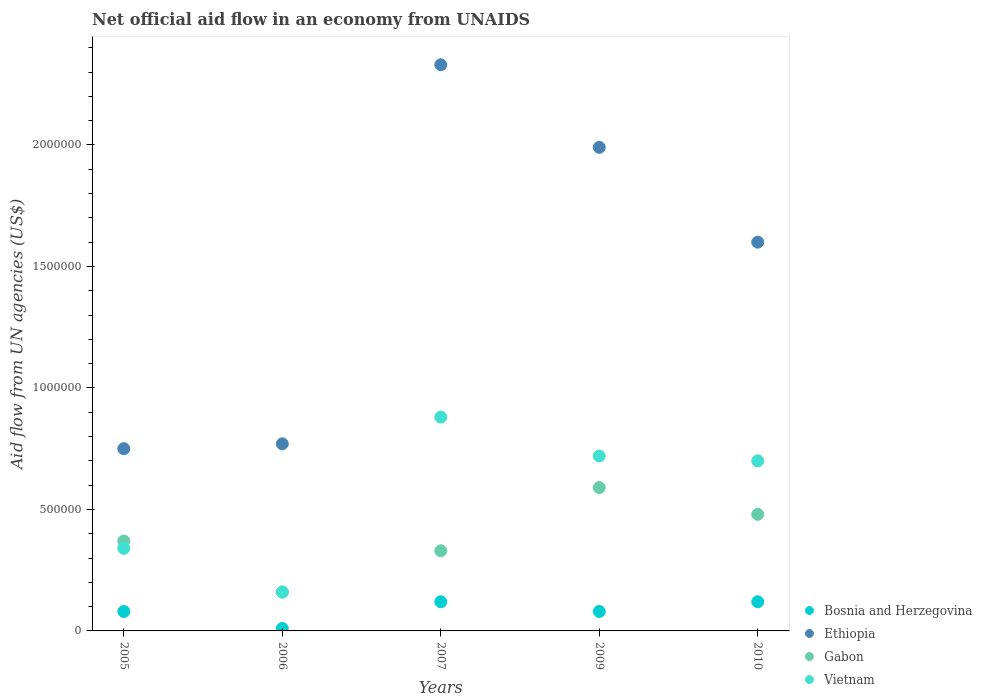How many different coloured dotlines are there?
Offer a very short reply. 4. Is the number of dotlines equal to the number of legend labels?
Offer a very short reply. Yes. What is the net official aid flow in Ethiopia in 2006?
Provide a short and direct response. 7.70e+05. Across all years, what is the maximum net official aid flow in Gabon?
Offer a terse response. 5.90e+05. Across all years, what is the minimum net official aid flow in Ethiopia?
Provide a succinct answer. 7.50e+05. In which year was the net official aid flow in Bosnia and Herzegovina maximum?
Your response must be concise. 2007. What is the total net official aid flow in Gabon in the graph?
Your answer should be very brief. 1.93e+06. What is the difference between the net official aid flow in Ethiopia in 2007 and that in 2009?
Make the answer very short. 3.40e+05. What is the difference between the net official aid flow in Gabon in 2006 and the net official aid flow in Ethiopia in 2005?
Provide a succinct answer. -5.90e+05. What is the average net official aid flow in Ethiopia per year?
Provide a short and direct response. 1.49e+06. In the year 2010, what is the difference between the net official aid flow in Bosnia and Herzegovina and net official aid flow in Gabon?
Keep it short and to the point. -3.60e+05. What is the ratio of the net official aid flow in Bosnia and Herzegovina in 2006 to that in 2007?
Offer a terse response. 0.08. Is the net official aid flow in Ethiopia in 2006 less than that in 2007?
Keep it short and to the point. Yes. Is the difference between the net official aid flow in Bosnia and Herzegovina in 2005 and 2006 greater than the difference between the net official aid flow in Gabon in 2005 and 2006?
Offer a terse response. No. What is the difference between the highest and the second highest net official aid flow in Vietnam?
Provide a short and direct response. 1.60e+05. What is the difference between the highest and the lowest net official aid flow in Bosnia and Herzegovina?
Your answer should be compact. 1.10e+05. Is it the case that in every year, the sum of the net official aid flow in Bosnia and Herzegovina and net official aid flow in Ethiopia  is greater than the sum of net official aid flow in Vietnam and net official aid flow in Gabon?
Keep it short and to the point. Yes. Does the net official aid flow in Gabon monotonically increase over the years?
Make the answer very short. No. Is the net official aid flow in Vietnam strictly less than the net official aid flow in Ethiopia over the years?
Offer a terse response. Yes. How many dotlines are there?
Your response must be concise. 4. How many years are there in the graph?
Keep it short and to the point. 5. Does the graph contain any zero values?
Ensure brevity in your answer.  No. Does the graph contain grids?
Give a very brief answer. No. Where does the legend appear in the graph?
Your answer should be very brief. Bottom right. How many legend labels are there?
Your answer should be compact. 4. How are the legend labels stacked?
Offer a very short reply. Vertical. What is the title of the graph?
Give a very brief answer. Net official aid flow in an economy from UNAIDS. Does "Fiji" appear as one of the legend labels in the graph?
Your response must be concise. No. What is the label or title of the Y-axis?
Keep it short and to the point. Aid flow from UN agencies (US$). What is the Aid flow from UN agencies (US$) in Ethiopia in 2005?
Your response must be concise. 7.50e+05. What is the Aid flow from UN agencies (US$) in Gabon in 2005?
Provide a succinct answer. 3.70e+05. What is the Aid flow from UN agencies (US$) of Vietnam in 2005?
Ensure brevity in your answer.  3.40e+05. What is the Aid flow from UN agencies (US$) in Bosnia and Herzegovina in 2006?
Keep it short and to the point. 10000. What is the Aid flow from UN agencies (US$) of Ethiopia in 2006?
Your answer should be very brief. 7.70e+05. What is the Aid flow from UN agencies (US$) in Bosnia and Herzegovina in 2007?
Offer a very short reply. 1.20e+05. What is the Aid flow from UN agencies (US$) of Ethiopia in 2007?
Make the answer very short. 2.33e+06. What is the Aid flow from UN agencies (US$) of Vietnam in 2007?
Keep it short and to the point. 8.80e+05. What is the Aid flow from UN agencies (US$) in Ethiopia in 2009?
Keep it short and to the point. 1.99e+06. What is the Aid flow from UN agencies (US$) in Gabon in 2009?
Keep it short and to the point. 5.90e+05. What is the Aid flow from UN agencies (US$) of Vietnam in 2009?
Provide a short and direct response. 7.20e+05. What is the Aid flow from UN agencies (US$) in Ethiopia in 2010?
Offer a terse response. 1.60e+06. What is the Aid flow from UN agencies (US$) of Gabon in 2010?
Ensure brevity in your answer.  4.80e+05. What is the Aid flow from UN agencies (US$) in Vietnam in 2010?
Make the answer very short. 7.00e+05. Across all years, what is the maximum Aid flow from UN agencies (US$) in Ethiopia?
Make the answer very short. 2.33e+06. Across all years, what is the maximum Aid flow from UN agencies (US$) of Gabon?
Give a very brief answer. 5.90e+05. Across all years, what is the maximum Aid flow from UN agencies (US$) of Vietnam?
Your answer should be very brief. 8.80e+05. Across all years, what is the minimum Aid flow from UN agencies (US$) in Bosnia and Herzegovina?
Provide a short and direct response. 10000. Across all years, what is the minimum Aid flow from UN agencies (US$) in Ethiopia?
Ensure brevity in your answer.  7.50e+05. What is the total Aid flow from UN agencies (US$) of Bosnia and Herzegovina in the graph?
Keep it short and to the point. 4.10e+05. What is the total Aid flow from UN agencies (US$) of Ethiopia in the graph?
Make the answer very short. 7.44e+06. What is the total Aid flow from UN agencies (US$) of Gabon in the graph?
Your response must be concise. 1.93e+06. What is the total Aid flow from UN agencies (US$) of Vietnam in the graph?
Keep it short and to the point. 2.80e+06. What is the difference between the Aid flow from UN agencies (US$) of Bosnia and Herzegovina in 2005 and that in 2006?
Your response must be concise. 7.00e+04. What is the difference between the Aid flow from UN agencies (US$) of Gabon in 2005 and that in 2006?
Provide a short and direct response. 2.10e+05. What is the difference between the Aid flow from UN agencies (US$) of Ethiopia in 2005 and that in 2007?
Offer a very short reply. -1.58e+06. What is the difference between the Aid flow from UN agencies (US$) in Gabon in 2005 and that in 2007?
Ensure brevity in your answer.  4.00e+04. What is the difference between the Aid flow from UN agencies (US$) of Vietnam in 2005 and that in 2007?
Your response must be concise. -5.40e+05. What is the difference between the Aid flow from UN agencies (US$) of Ethiopia in 2005 and that in 2009?
Keep it short and to the point. -1.24e+06. What is the difference between the Aid flow from UN agencies (US$) of Gabon in 2005 and that in 2009?
Your answer should be compact. -2.20e+05. What is the difference between the Aid flow from UN agencies (US$) in Vietnam in 2005 and that in 2009?
Keep it short and to the point. -3.80e+05. What is the difference between the Aid flow from UN agencies (US$) in Bosnia and Herzegovina in 2005 and that in 2010?
Make the answer very short. -4.00e+04. What is the difference between the Aid flow from UN agencies (US$) in Ethiopia in 2005 and that in 2010?
Give a very brief answer. -8.50e+05. What is the difference between the Aid flow from UN agencies (US$) of Vietnam in 2005 and that in 2010?
Give a very brief answer. -3.60e+05. What is the difference between the Aid flow from UN agencies (US$) of Ethiopia in 2006 and that in 2007?
Your answer should be very brief. -1.56e+06. What is the difference between the Aid flow from UN agencies (US$) in Vietnam in 2006 and that in 2007?
Ensure brevity in your answer.  -7.20e+05. What is the difference between the Aid flow from UN agencies (US$) in Bosnia and Herzegovina in 2006 and that in 2009?
Your response must be concise. -7.00e+04. What is the difference between the Aid flow from UN agencies (US$) in Ethiopia in 2006 and that in 2009?
Provide a short and direct response. -1.22e+06. What is the difference between the Aid flow from UN agencies (US$) of Gabon in 2006 and that in 2009?
Offer a terse response. -4.30e+05. What is the difference between the Aid flow from UN agencies (US$) in Vietnam in 2006 and that in 2009?
Give a very brief answer. -5.60e+05. What is the difference between the Aid flow from UN agencies (US$) in Bosnia and Herzegovina in 2006 and that in 2010?
Offer a terse response. -1.10e+05. What is the difference between the Aid flow from UN agencies (US$) in Ethiopia in 2006 and that in 2010?
Provide a short and direct response. -8.30e+05. What is the difference between the Aid flow from UN agencies (US$) of Gabon in 2006 and that in 2010?
Your response must be concise. -3.20e+05. What is the difference between the Aid flow from UN agencies (US$) of Vietnam in 2006 and that in 2010?
Keep it short and to the point. -5.40e+05. What is the difference between the Aid flow from UN agencies (US$) of Bosnia and Herzegovina in 2007 and that in 2009?
Offer a terse response. 4.00e+04. What is the difference between the Aid flow from UN agencies (US$) in Gabon in 2007 and that in 2009?
Provide a succinct answer. -2.60e+05. What is the difference between the Aid flow from UN agencies (US$) of Vietnam in 2007 and that in 2009?
Offer a terse response. 1.60e+05. What is the difference between the Aid flow from UN agencies (US$) of Bosnia and Herzegovina in 2007 and that in 2010?
Ensure brevity in your answer.  0. What is the difference between the Aid flow from UN agencies (US$) in Ethiopia in 2007 and that in 2010?
Provide a succinct answer. 7.30e+05. What is the difference between the Aid flow from UN agencies (US$) of Vietnam in 2007 and that in 2010?
Give a very brief answer. 1.80e+05. What is the difference between the Aid flow from UN agencies (US$) of Ethiopia in 2009 and that in 2010?
Offer a terse response. 3.90e+05. What is the difference between the Aid flow from UN agencies (US$) in Gabon in 2009 and that in 2010?
Make the answer very short. 1.10e+05. What is the difference between the Aid flow from UN agencies (US$) of Bosnia and Herzegovina in 2005 and the Aid flow from UN agencies (US$) of Ethiopia in 2006?
Offer a very short reply. -6.90e+05. What is the difference between the Aid flow from UN agencies (US$) of Bosnia and Herzegovina in 2005 and the Aid flow from UN agencies (US$) of Vietnam in 2006?
Offer a very short reply. -8.00e+04. What is the difference between the Aid flow from UN agencies (US$) in Ethiopia in 2005 and the Aid flow from UN agencies (US$) in Gabon in 2006?
Ensure brevity in your answer.  5.90e+05. What is the difference between the Aid flow from UN agencies (US$) of Ethiopia in 2005 and the Aid flow from UN agencies (US$) of Vietnam in 2006?
Your answer should be compact. 5.90e+05. What is the difference between the Aid flow from UN agencies (US$) in Gabon in 2005 and the Aid flow from UN agencies (US$) in Vietnam in 2006?
Keep it short and to the point. 2.10e+05. What is the difference between the Aid flow from UN agencies (US$) of Bosnia and Herzegovina in 2005 and the Aid flow from UN agencies (US$) of Ethiopia in 2007?
Your response must be concise. -2.25e+06. What is the difference between the Aid flow from UN agencies (US$) in Bosnia and Herzegovina in 2005 and the Aid flow from UN agencies (US$) in Vietnam in 2007?
Provide a succinct answer. -8.00e+05. What is the difference between the Aid flow from UN agencies (US$) of Ethiopia in 2005 and the Aid flow from UN agencies (US$) of Gabon in 2007?
Your response must be concise. 4.20e+05. What is the difference between the Aid flow from UN agencies (US$) of Gabon in 2005 and the Aid flow from UN agencies (US$) of Vietnam in 2007?
Ensure brevity in your answer.  -5.10e+05. What is the difference between the Aid flow from UN agencies (US$) in Bosnia and Herzegovina in 2005 and the Aid flow from UN agencies (US$) in Ethiopia in 2009?
Your answer should be compact. -1.91e+06. What is the difference between the Aid flow from UN agencies (US$) in Bosnia and Herzegovina in 2005 and the Aid flow from UN agencies (US$) in Gabon in 2009?
Offer a very short reply. -5.10e+05. What is the difference between the Aid flow from UN agencies (US$) of Bosnia and Herzegovina in 2005 and the Aid flow from UN agencies (US$) of Vietnam in 2009?
Give a very brief answer. -6.40e+05. What is the difference between the Aid flow from UN agencies (US$) of Ethiopia in 2005 and the Aid flow from UN agencies (US$) of Vietnam in 2009?
Provide a short and direct response. 3.00e+04. What is the difference between the Aid flow from UN agencies (US$) in Gabon in 2005 and the Aid flow from UN agencies (US$) in Vietnam in 2009?
Keep it short and to the point. -3.50e+05. What is the difference between the Aid flow from UN agencies (US$) of Bosnia and Herzegovina in 2005 and the Aid flow from UN agencies (US$) of Ethiopia in 2010?
Keep it short and to the point. -1.52e+06. What is the difference between the Aid flow from UN agencies (US$) of Bosnia and Herzegovina in 2005 and the Aid flow from UN agencies (US$) of Gabon in 2010?
Keep it short and to the point. -4.00e+05. What is the difference between the Aid flow from UN agencies (US$) of Bosnia and Herzegovina in 2005 and the Aid flow from UN agencies (US$) of Vietnam in 2010?
Give a very brief answer. -6.20e+05. What is the difference between the Aid flow from UN agencies (US$) in Ethiopia in 2005 and the Aid flow from UN agencies (US$) in Vietnam in 2010?
Provide a succinct answer. 5.00e+04. What is the difference between the Aid flow from UN agencies (US$) in Gabon in 2005 and the Aid flow from UN agencies (US$) in Vietnam in 2010?
Offer a terse response. -3.30e+05. What is the difference between the Aid flow from UN agencies (US$) in Bosnia and Herzegovina in 2006 and the Aid flow from UN agencies (US$) in Ethiopia in 2007?
Your response must be concise. -2.32e+06. What is the difference between the Aid flow from UN agencies (US$) in Bosnia and Herzegovina in 2006 and the Aid flow from UN agencies (US$) in Gabon in 2007?
Offer a very short reply. -3.20e+05. What is the difference between the Aid flow from UN agencies (US$) in Bosnia and Herzegovina in 2006 and the Aid flow from UN agencies (US$) in Vietnam in 2007?
Make the answer very short. -8.70e+05. What is the difference between the Aid flow from UN agencies (US$) of Ethiopia in 2006 and the Aid flow from UN agencies (US$) of Gabon in 2007?
Offer a terse response. 4.40e+05. What is the difference between the Aid flow from UN agencies (US$) in Gabon in 2006 and the Aid flow from UN agencies (US$) in Vietnam in 2007?
Provide a succinct answer. -7.20e+05. What is the difference between the Aid flow from UN agencies (US$) of Bosnia and Herzegovina in 2006 and the Aid flow from UN agencies (US$) of Ethiopia in 2009?
Ensure brevity in your answer.  -1.98e+06. What is the difference between the Aid flow from UN agencies (US$) of Bosnia and Herzegovina in 2006 and the Aid flow from UN agencies (US$) of Gabon in 2009?
Keep it short and to the point. -5.80e+05. What is the difference between the Aid flow from UN agencies (US$) in Bosnia and Herzegovina in 2006 and the Aid flow from UN agencies (US$) in Vietnam in 2009?
Ensure brevity in your answer.  -7.10e+05. What is the difference between the Aid flow from UN agencies (US$) in Ethiopia in 2006 and the Aid flow from UN agencies (US$) in Gabon in 2009?
Keep it short and to the point. 1.80e+05. What is the difference between the Aid flow from UN agencies (US$) of Gabon in 2006 and the Aid flow from UN agencies (US$) of Vietnam in 2009?
Your answer should be very brief. -5.60e+05. What is the difference between the Aid flow from UN agencies (US$) of Bosnia and Herzegovina in 2006 and the Aid flow from UN agencies (US$) of Ethiopia in 2010?
Provide a succinct answer. -1.59e+06. What is the difference between the Aid flow from UN agencies (US$) in Bosnia and Herzegovina in 2006 and the Aid flow from UN agencies (US$) in Gabon in 2010?
Provide a short and direct response. -4.70e+05. What is the difference between the Aid flow from UN agencies (US$) of Bosnia and Herzegovina in 2006 and the Aid flow from UN agencies (US$) of Vietnam in 2010?
Offer a very short reply. -6.90e+05. What is the difference between the Aid flow from UN agencies (US$) in Gabon in 2006 and the Aid flow from UN agencies (US$) in Vietnam in 2010?
Offer a terse response. -5.40e+05. What is the difference between the Aid flow from UN agencies (US$) in Bosnia and Herzegovina in 2007 and the Aid flow from UN agencies (US$) in Ethiopia in 2009?
Offer a terse response. -1.87e+06. What is the difference between the Aid flow from UN agencies (US$) in Bosnia and Herzegovina in 2007 and the Aid flow from UN agencies (US$) in Gabon in 2009?
Provide a short and direct response. -4.70e+05. What is the difference between the Aid flow from UN agencies (US$) in Bosnia and Herzegovina in 2007 and the Aid flow from UN agencies (US$) in Vietnam in 2009?
Offer a terse response. -6.00e+05. What is the difference between the Aid flow from UN agencies (US$) in Ethiopia in 2007 and the Aid flow from UN agencies (US$) in Gabon in 2009?
Give a very brief answer. 1.74e+06. What is the difference between the Aid flow from UN agencies (US$) in Ethiopia in 2007 and the Aid flow from UN agencies (US$) in Vietnam in 2009?
Give a very brief answer. 1.61e+06. What is the difference between the Aid flow from UN agencies (US$) in Gabon in 2007 and the Aid flow from UN agencies (US$) in Vietnam in 2009?
Provide a succinct answer. -3.90e+05. What is the difference between the Aid flow from UN agencies (US$) in Bosnia and Herzegovina in 2007 and the Aid flow from UN agencies (US$) in Ethiopia in 2010?
Offer a very short reply. -1.48e+06. What is the difference between the Aid flow from UN agencies (US$) in Bosnia and Herzegovina in 2007 and the Aid flow from UN agencies (US$) in Gabon in 2010?
Your answer should be very brief. -3.60e+05. What is the difference between the Aid flow from UN agencies (US$) of Bosnia and Herzegovina in 2007 and the Aid flow from UN agencies (US$) of Vietnam in 2010?
Make the answer very short. -5.80e+05. What is the difference between the Aid flow from UN agencies (US$) of Ethiopia in 2007 and the Aid flow from UN agencies (US$) of Gabon in 2010?
Give a very brief answer. 1.85e+06. What is the difference between the Aid flow from UN agencies (US$) in Ethiopia in 2007 and the Aid flow from UN agencies (US$) in Vietnam in 2010?
Provide a short and direct response. 1.63e+06. What is the difference between the Aid flow from UN agencies (US$) in Gabon in 2007 and the Aid flow from UN agencies (US$) in Vietnam in 2010?
Make the answer very short. -3.70e+05. What is the difference between the Aid flow from UN agencies (US$) of Bosnia and Herzegovina in 2009 and the Aid flow from UN agencies (US$) of Ethiopia in 2010?
Ensure brevity in your answer.  -1.52e+06. What is the difference between the Aid flow from UN agencies (US$) in Bosnia and Herzegovina in 2009 and the Aid flow from UN agencies (US$) in Gabon in 2010?
Your answer should be very brief. -4.00e+05. What is the difference between the Aid flow from UN agencies (US$) of Bosnia and Herzegovina in 2009 and the Aid flow from UN agencies (US$) of Vietnam in 2010?
Offer a very short reply. -6.20e+05. What is the difference between the Aid flow from UN agencies (US$) of Ethiopia in 2009 and the Aid flow from UN agencies (US$) of Gabon in 2010?
Your response must be concise. 1.51e+06. What is the difference between the Aid flow from UN agencies (US$) in Ethiopia in 2009 and the Aid flow from UN agencies (US$) in Vietnam in 2010?
Make the answer very short. 1.29e+06. What is the average Aid flow from UN agencies (US$) in Bosnia and Herzegovina per year?
Give a very brief answer. 8.20e+04. What is the average Aid flow from UN agencies (US$) in Ethiopia per year?
Your answer should be very brief. 1.49e+06. What is the average Aid flow from UN agencies (US$) of Gabon per year?
Your answer should be very brief. 3.86e+05. What is the average Aid flow from UN agencies (US$) in Vietnam per year?
Provide a short and direct response. 5.60e+05. In the year 2005, what is the difference between the Aid flow from UN agencies (US$) in Bosnia and Herzegovina and Aid flow from UN agencies (US$) in Ethiopia?
Give a very brief answer. -6.70e+05. In the year 2005, what is the difference between the Aid flow from UN agencies (US$) of Bosnia and Herzegovina and Aid flow from UN agencies (US$) of Gabon?
Your answer should be compact. -2.90e+05. In the year 2005, what is the difference between the Aid flow from UN agencies (US$) in Bosnia and Herzegovina and Aid flow from UN agencies (US$) in Vietnam?
Provide a succinct answer. -2.60e+05. In the year 2005, what is the difference between the Aid flow from UN agencies (US$) of Ethiopia and Aid flow from UN agencies (US$) of Vietnam?
Keep it short and to the point. 4.10e+05. In the year 2005, what is the difference between the Aid flow from UN agencies (US$) in Gabon and Aid flow from UN agencies (US$) in Vietnam?
Your answer should be very brief. 3.00e+04. In the year 2006, what is the difference between the Aid flow from UN agencies (US$) of Bosnia and Herzegovina and Aid flow from UN agencies (US$) of Ethiopia?
Offer a very short reply. -7.60e+05. In the year 2006, what is the difference between the Aid flow from UN agencies (US$) of Bosnia and Herzegovina and Aid flow from UN agencies (US$) of Vietnam?
Provide a short and direct response. -1.50e+05. In the year 2006, what is the difference between the Aid flow from UN agencies (US$) in Ethiopia and Aid flow from UN agencies (US$) in Gabon?
Ensure brevity in your answer.  6.10e+05. In the year 2006, what is the difference between the Aid flow from UN agencies (US$) of Ethiopia and Aid flow from UN agencies (US$) of Vietnam?
Make the answer very short. 6.10e+05. In the year 2006, what is the difference between the Aid flow from UN agencies (US$) in Gabon and Aid flow from UN agencies (US$) in Vietnam?
Your response must be concise. 0. In the year 2007, what is the difference between the Aid flow from UN agencies (US$) in Bosnia and Herzegovina and Aid flow from UN agencies (US$) in Ethiopia?
Make the answer very short. -2.21e+06. In the year 2007, what is the difference between the Aid flow from UN agencies (US$) of Bosnia and Herzegovina and Aid flow from UN agencies (US$) of Vietnam?
Your answer should be compact. -7.60e+05. In the year 2007, what is the difference between the Aid flow from UN agencies (US$) of Ethiopia and Aid flow from UN agencies (US$) of Gabon?
Make the answer very short. 2.00e+06. In the year 2007, what is the difference between the Aid flow from UN agencies (US$) in Ethiopia and Aid flow from UN agencies (US$) in Vietnam?
Offer a very short reply. 1.45e+06. In the year 2007, what is the difference between the Aid flow from UN agencies (US$) of Gabon and Aid flow from UN agencies (US$) of Vietnam?
Keep it short and to the point. -5.50e+05. In the year 2009, what is the difference between the Aid flow from UN agencies (US$) of Bosnia and Herzegovina and Aid flow from UN agencies (US$) of Ethiopia?
Your response must be concise. -1.91e+06. In the year 2009, what is the difference between the Aid flow from UN agencies (US$) in Bosnia and Herzegovina and Aid flow from UN agencies (US$) in Gabon?
Give a very brief answer. -5.10e+05. In the year 2009, what is the difference between the Aid flow from UN agencies (US$) in Bosnia and Herzegovina and Aid flow from UN agencies (US$) in Vietnam?
Provide a succinct answer. -6.40e+05. In the year 2009, what is the difference between the Aid flow from UN agencies (US$) of Ethiopia and Aid flow from UN agencies (US$) of Gabon?
Your answer should be very brief. 1.40e+06. In the year 2009, what is the difference between the Aid flow from UN agencies (US$) in Ethiopia and Aid flow from UN agencies (US$) in Vietnam?
Give a very brief answer. 1.27e+06. In the year 2009, what is the difference between the Aid flow from UN agencies (US$) in Gabon and Aid flow from UN agencies (US$) in Vietnam?
Your answer should be compact. -1.30e+05. In the year 2010, what is the difference between the Aid flow from UN agencies (US$) in Bosnia and Herzegovina and Aid flow from UN agencies (US$) in Ethiopia?
Your answer should be very brief. -1.48e+06. In the year 2010, what is the difference between the Aid flow from UN agencies (US$) in Bosnia and Herzegovina and Aid flow from UN agencies (US$) in Gabon?
Make the answer very short. -3.60e+05. In the year 2010, what is the difference between the Aid flow from UN agencies (US$) in Bosnia and Herzegovina and Aid flow from UN agencies (US$) in Vietnam?
Ensure brevity in your answer.  -5.80e+05. In the year 2010, what is the difference between the Aid flow from UN agencies (US$) in Ethiopia and Aid flow from UN agencies (US$) in Gabon?
Make the answer very short. 1.12e+06. In the year 2010, what is the difference between the Aid flow from UN agencies (US$) in Gabon and Aid flow from UN agencies (US$) in Vietnam?
Make the answer very short. -2.20e+05. What is the ratio of the Aid flow from UN agencies (US$) in Bosnia and Herzegovina in 2005 to that in 2006?
Make the answer very short. 8. What is the ratio of the Aid flow from UN agencies (US$) of Gabon in 2005 to that in 2006?
Your answer should be compact. 2.31. What is the ratio of the Aid flow from UN agencies (US$) in Vietnam in 2005 to that in 2006?
Ensure brevity in your answer.  2.12. What is the ratio of the Aid flow from UN agencies (US$) in Bosnia and Herzegovina in 2005 to that in 2007?
Your answer should be compact. 0.67. What is the ratio of the Aid flow from UN agencies (US$) of Ethiopia in 2005 to that in 2007?
Your answer should be very brief. 0.32. What is the ratio of the Aid flow from UN agencies (US$) of Gabon in 2005 to that in 2007?
Give a very brief answer. 1.12. What is the ratio of the Aid flow from UN agencies (US$) in Vietnam in 2005 to that in 2007?
Keep it short and to the point. 0.39. What is the ratio of the Aid flow from UN agencies (US$) of Ethiopia in 2005 to that in 2009?
Offer a very short reply. 0.38. What is the ratio of the Aid flow from UN agencies (US$) of Gabon in 2005 to that in 2009?
Offer a terse response. 0.63. What is the ratio of the Aid flow from UN agencies (US$) of Vietnam in 2005 to that in 2009?
Your answer should be compact. 0.47. What is the ratio of the Aid flow from UN agencies (US$) of Bosnia and Herzegovina in 2005 to that in 2010?
Your response must be concise. 0.67. What is the ratio of the Aid flow from UN agencies (US$) of Ethiopia in 2005 to that in 2010?
Your answer should be compact. 0.47. What is the ratio of the Aid flow from UN agencies (US$) of Gabon in 2005 to that in 2010?
Ensure brevity in your answer.  0.77. What is the ratio of the Aid flow from UN agencies (US$) in Vietnam in 2005 to that in 2010?
Offer a terse response. 0.49. What is the ratio of the Aid flow from UN agencies (US$) in Bosnia and Herzegovina in 2006 to that in 2007?
Give a very brief answer. 0.08. What is the ratio of the Aid flow from UN agencies (US$) of Ethiopia in 2006 to that in 2007?
Provide a short and direct response. 0.33. What is the ratio of the Aid flow from UN agencies (US$) in Gabon in 2006 to that in 2007?
Keep it short and to the point. 0.48. What is the ratio of the Aid flow from UN agencies (US$) in Vietnam in 2006 to that in 2007?
Offer a very short reply. 0.18. What is the ratio of the Aid flow from UN agencies (US$) in Ethiopia in 2006 to that in 2009?
Your response must be concise. 0.39. What is the ratio of the Aid flow from UN agencies (US$) of Gabon in 2006 to that in 2009?
Give a very brief answer. 0.27. What is the ratio of the Aid flow from UN agencies (US$) in Vietnam in 2006 to that in 2009?
Your response must be concise. 0.22. What is the ratio of the Aid flow from UN agencies (US$) in Bosnia and Herzegovina in 2006 to that in 2010?
Give a very brief answer. 0.08. What is the ratio of the Aid flow from UN agencies (US$) of Ethiopia in 2006 to that in 2010?
Your answer should be very brief. 0.48. What is the ratio of the Aid flow from UN agencies (US$) in Vietnam in 2006 to that in 2010?
Offer a very short reply. 0.23. What is the ratio of the Aid flow from UN agencies (US$) of Ethiopia in 2007 to that in 2009?
Make the answer very short. 1.17. What is the ratio of the Aid flow from UN agencies (US$) of Gabon in 2007 to that in 2009?
Make the answer very short. 0.56. What is the ratio of the Aid flow from UN agencies (US$) in Vietnam in 2007 to that in 2009?
Provide a short and direct response. 1.22. What is the ratio of the Aid flow from UN agencies (US$) in Ethiopia in 2007 to that in 2010?
Provide a succinct answer. 1.46. What is the ratio of the Aid flow from UN agencies (US$) in Gabon in 2007 to that in 2010?
Your answer should be compact. 0.69. What is the ratio of the Aid flow from UN agencies (US$) of Vietnam in 2007 to that in 2010?
Your response must be concise. 1.26. What is the ratio of the Aid flow from UN agencies (US$) in Ethiopia in 2009 to that in 2010?
Provide a succinct answer. 1.24. What is the ratio of the Aid flow from UN agencies (US$) of Gabon in 2009 to that in 2010?
Offer a very short reply. 1.23. What is the ratio of the Aid flow from UN agencies (US$) of Vietnam in 2009 to that in 2010?
Keep it short and to the point. 1.03. What is the difference between the highest and the second highest Aid flow from UN agencies (US$) in Bosnia and Herzegovina?
Provide a succinct answer. 0. What is the difference between the highest and the second highest Aid flow from UN agencies (US$) of Ethiopia?
Provide a succinct answer. 3.40e+05. What is the difference between the highest and the second highest Aid flow from UN agencies (US$) of Vietnam?
Your answer should be very brief. 1.60e+05. What is the difference between the highest and the lowest Aid flow from UN agencies (US$) of Bosnia and Herzegovina?
Offer a terse response. 1.10e+05. What is the difference between the highest and the lowest Aid flow from UN agencies (US$) of Ethiopia?
Offer a very short reply. 1.58e+06. What is the difference between the highest and the lowest Aid flow from UN agencies (US$) of Gabon?
Provide a succinct answer. 4.30e+05. What is the difference between the highest and the lowest Aid flow from UN agencies (US$) in Vietnam?
Your response must be concise. 7.20e+05. 